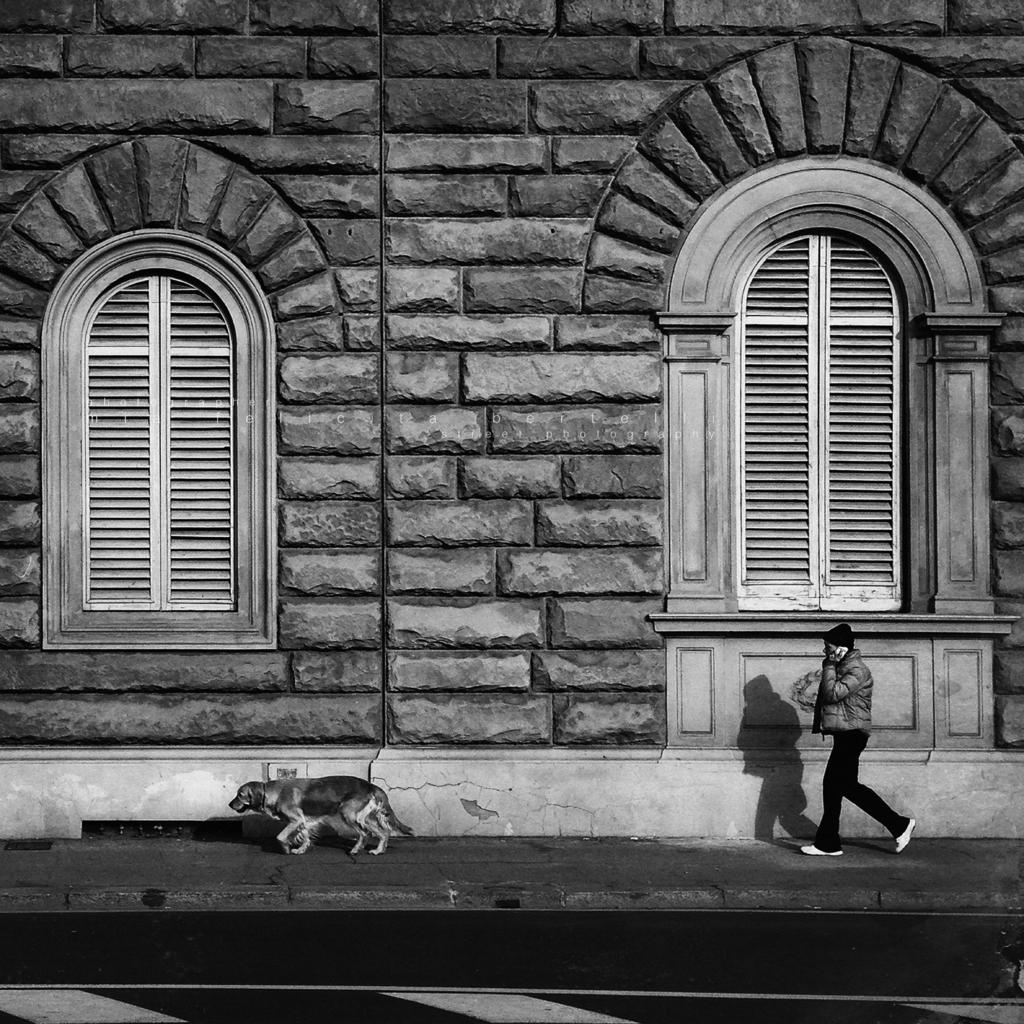What is the man in the image doing? The man is walking in the image. What is the dog in the image doing? The dog is running in the image. What can be seen in the background of the image? There is a wall in the image. How many windows are visible in the image? There are two white-colored windows in the image. Where is the throne located in the image? There is no throne present in the image. What plot is being carried out by the man and the dog in the image? The image does not depict a plot or any specific storyline involving the man and the dog. 